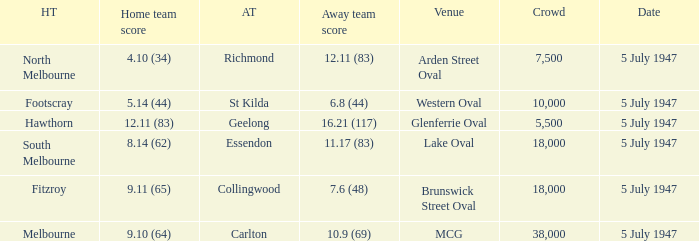11 (83)? 4.10 (34). 